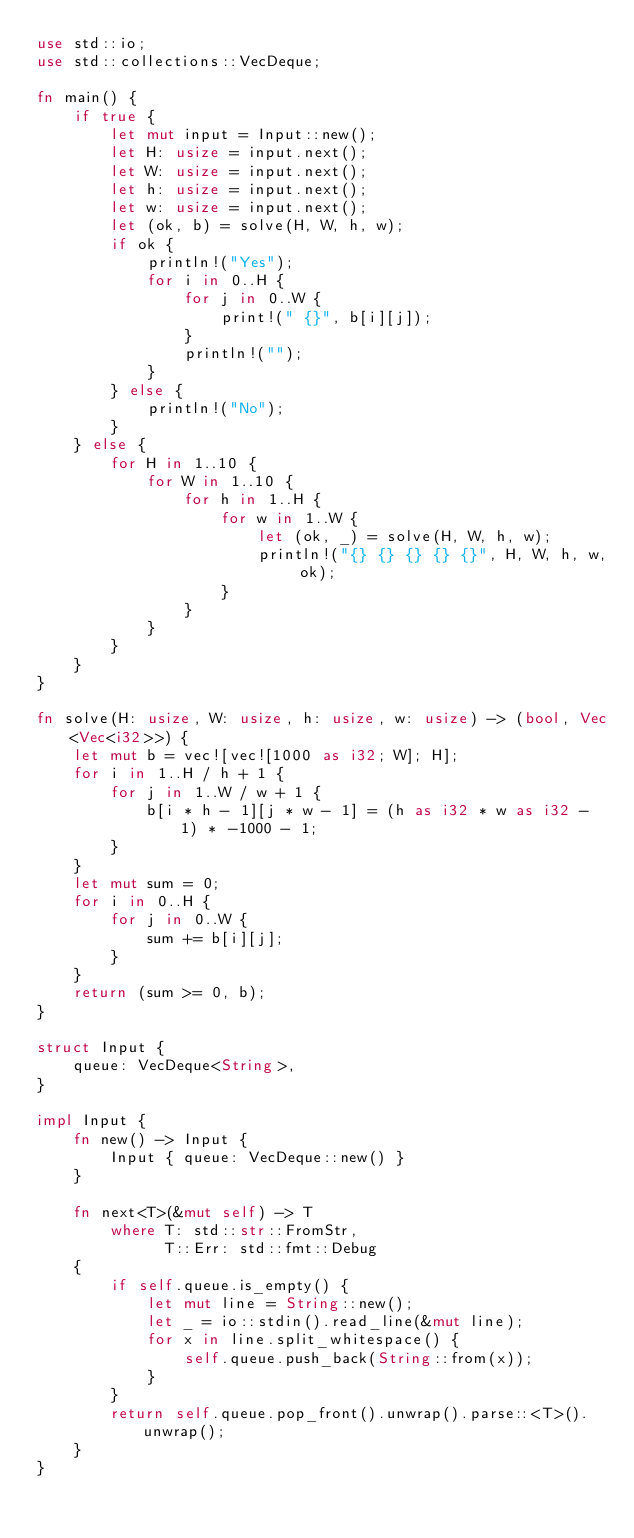<code> <loc_0><loc_0><loc_500><loc_500><_Rust_>use std::io;
use std::collections::VecDeque;

fn main() {
    if true {
        let mut input = Input::new();
        let H: usize = input.next();
        let W: usize = input.next();
        let h: usize = input.next();
        let w: usize = input.next();
        let (ok, b) = solve(H, W, h, w);
        if ok {
            println!("Yes");
            for i in 0..H {
                for j in 0..W {
                    print!(" {}", b[i][j]);
                }
                println!("");
            }
        } else {
            println!("No");
        }
    } else {
        for H in 1..10 {
            for W in 1..10 {
                for h in 1..H {
                    for w in 1..W {
                        let (ok, _) = solve(H, W, h, w);
                        println!("{} {} {} {} {}", H, W, h, w, ok);
                    }
                }
            }
        }
    }
}

fn solve(H: usize, W: usize, h: usize, w: usize) -> (bool, Vec<Vec<i32>>) {
    let mut b = vec![vec![1000 as i32; W]; H];
    for i in 1..H / h + 1 {
        for j in 1..W / w + 1 {
            b[i * h - 1][j * w - 1] = (h as i32 * w as i32 - 1) * -1000 - 1;
        }
    }
    let mut sum = 0;
    for i in 0..H {
        for j in 0..W {
            sum += b[i][j];
        }
    }
    return (sum >= 0, b);
}

struct Input {
    queue: VecDeque<String>,
}

impl Input {
    fn new() -> Input {
        Input { queue: VecDeque::new() }
    }

    fn next<T>(&mut self) -> T
        where T: std::str::FromStr,
              T::Err: std::fmt::Debug
    {
        if self.queue.is_empty() {
            let mut line = String::new();
            let _ = io::stdin().read_line(&mut line);
            for x in line.split_whitespace() {
                self.queue.push_back(String::from(x));
            }
        }
        return self.queue.pop_front().unwrap().parse::<T>().unwrap();
    }
}

</code> 